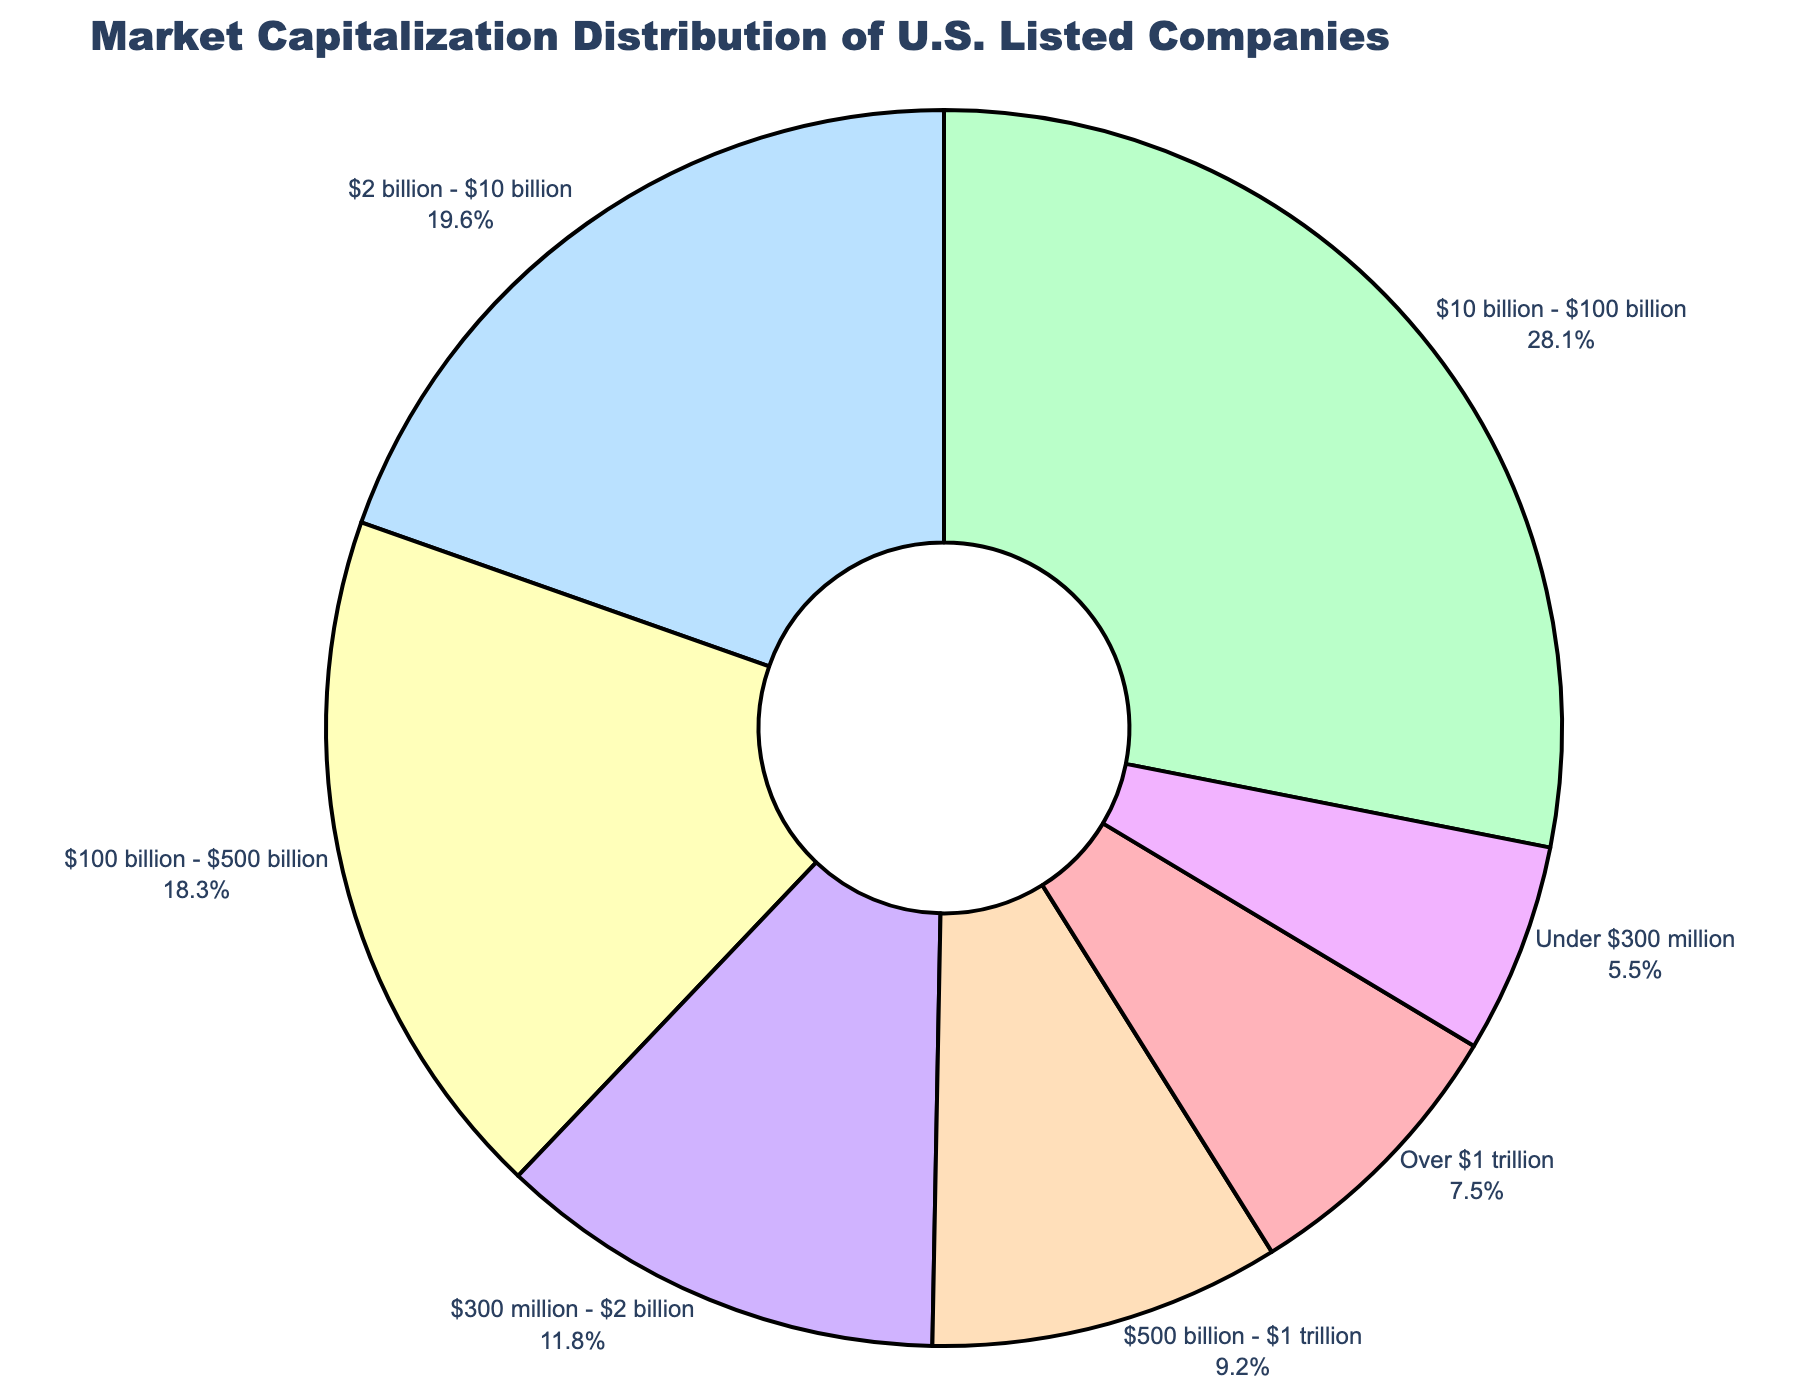What is the market cap range that represents the largest percentage of companies? The slice that represents the largest percentage is 28.1%, which corresponds to the "$10 billion - $100 billion" market cap range.
Answer: $10 billion - $100 billion Which market cap range has a smaller percentage than the $2 billion - $10 billion range but larger than the Under $300 million range? The $300 million - $2 billion range is 11.8%, which is smaller than the $2 billion - $10 billion range (19.6%) and larger than the Under $300 million range (5.5%).
Answer: $300 million - $2 billion How does the percentage of companies with a market cap over $1 trillion compare to those in the $2 billion - $10 billion range? The percentage of companies with a market cap over $1 trillion is 7.5%, while those in the $2 billion - $10 billion range represent 19.6%. To compare, 19.6% is significantly larger than 7.5%.
Answer: The $2 billion - $10 billion range is larger What is the combined percentage of companies with market caps between $100 billion - $1 trillion? The combined percentage of market caps between $100 billion - $500 billion is 18.3%, and $500 billion - $1 trillion is 9.2%. Adding them together: 18.3 + 9.2 = 27.5%.
Answer: 27.5% What is the total percentage of companies with market caps either below $300 million or over $500 billion? Companies below $300 million account for 5.5%, and those over $500 billion (adding ranges $500 billion - $1 trillion and Over $1 trillion) are 9.2% + 7.5% = 16.7%. Summing these: 5.5 + 16.7 = 22.2%.
Answer: 22.2% Which market cap range uses a red slice in the pie chart? According to the color scheme, the red slice in the pie chart represents the "Over $1 trillion" market cap range.
Answer: Over $1 trillion What is the difference in percentage between the largest and smallest market cap ranges? The largest market cap range is "$10 billion - $100 billion" at 28.1%, and the smallest is "Under $300 million" at 5.5%. The difference is calculated as: 28.1 - 5.5 = 22.6%.
Answer: 22.6% If you sum the percentages of the three smallest market cap ranges, what do you get? The percentages for the three smallest ranges are: Over $1 trillion (7.5%), Under $300 million (5.5%), and $300 million - $2 billion (11.8%). Summing these: 7.5 + 5.5 + 11.8 = 24.8%.
Answer: 24.8% How many market cap ranges have a percentage higher than 15%? The ranges with percentages higher than 15% are "$100 billion - $500 billion" (18.3%) and "$10 billion - $100 billion" (28.1%). This results in two market cap ranges.
Answer: Two 